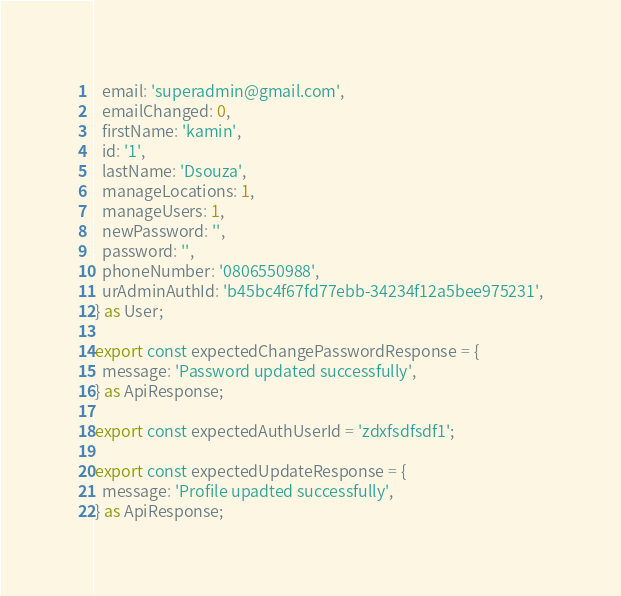<code> <loc_0><loc_0><loc_500><loc_500><_TypeScript_>  email: 'superadmin@gmail.com',
  emailChanged: 0,
  firstName: 'kamin',
  id: '1',
  lastName: 'Dsouza',
  manageLocations: 1,
  manageUsers: 1,
  newPassword: '',
  password: '',
  phoneNumber: '0806550988',
  urAdminAuthId: 'b45bc4f67fd77ebb-34234f12a5bee975231',
} as User;

export const expectedChangePasswordResponse = {
  message: 'Password updated successfully',
} as ApiResponse;

export const expectedAuthUserId = 'zdxfsdfsdf1';

export const expectedUpdateResponse = {
  message: 'Profile upadted successfully',
} as ApiResponse;
</code> 